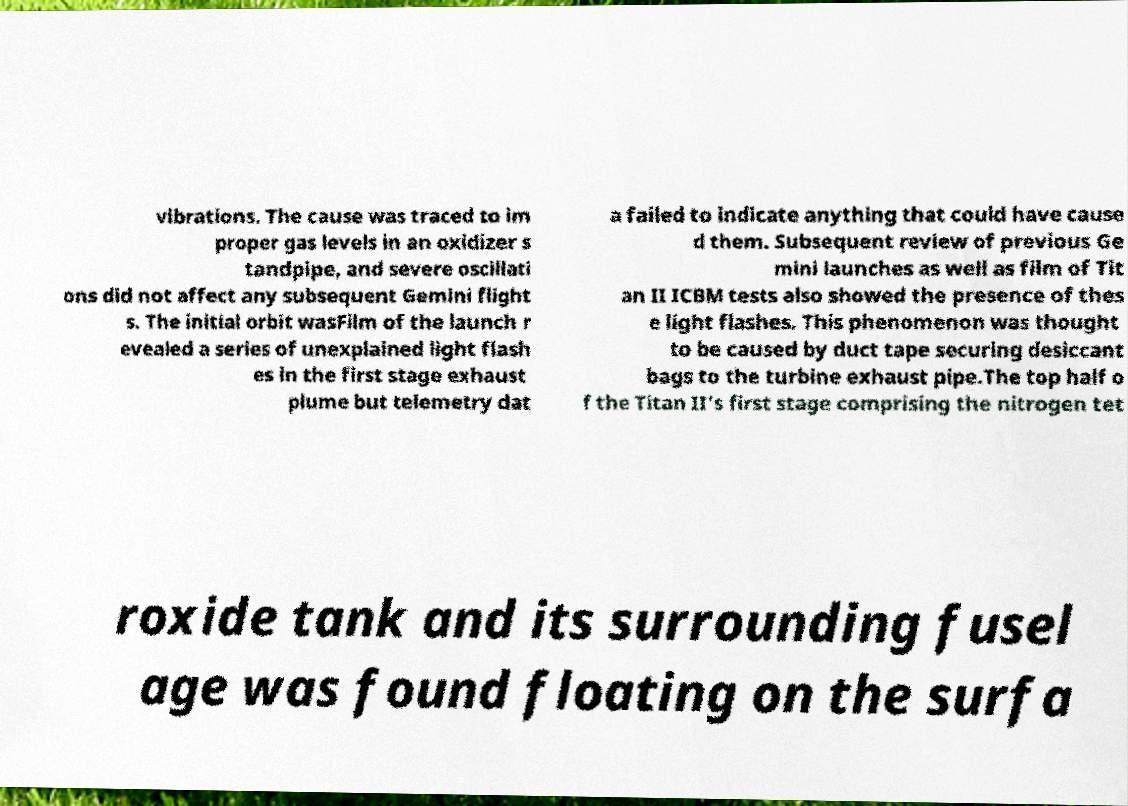Please identify and transcribe the text found in this image. vibrations. The cause was traced to im proper gas levels in an oxidizer s tandpipe, and severe oscillati ons did not affect any subsequent Gemini flight s. The initial orbit wasFilm of the launch r evealed a series of unexplained light flash es in the first stage exhaust plume but telemetry dat a failed to indicate anything that could have cause d them. Subsequent review of previous Ge mini launches as well as film of Tit an II ICBM tests also showed the presence of thes e light flashes. This phenomenon was thought to be caused by duct tape securing desiccant bags to the turbine exhaust pipe.The top half o f the Titan II's first stage comprising the nitrogen tet roxide tank and its surrounding fusel age was found floating on the surfa 